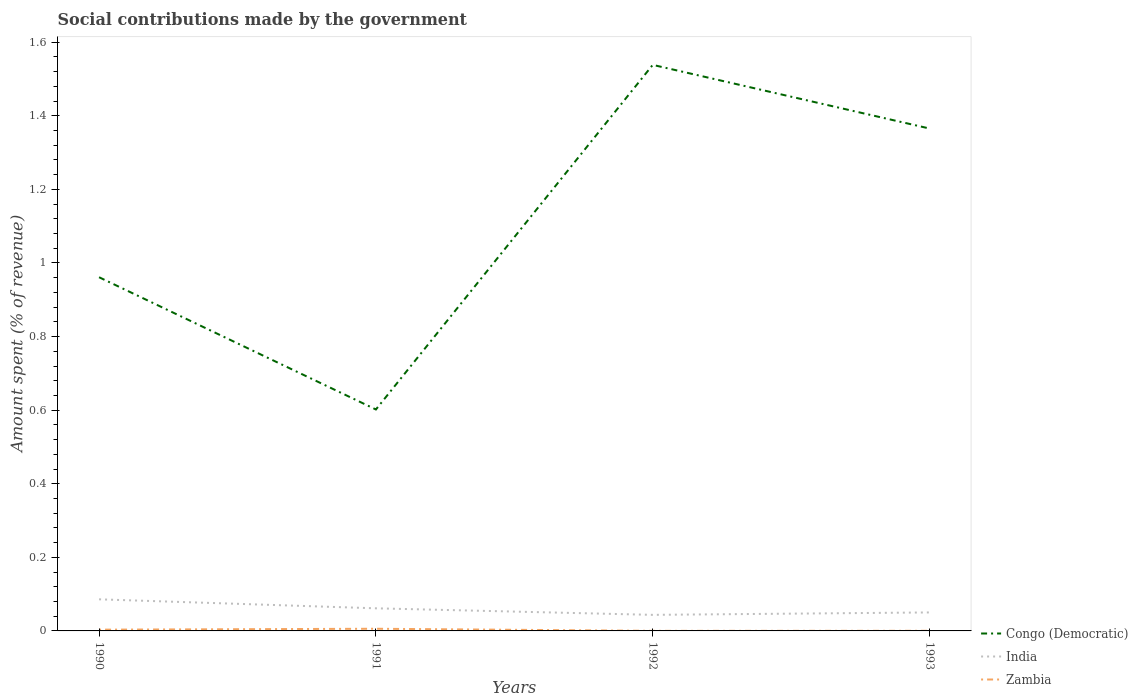Does the line corresponding to India intersect with the line corresponding to Zambia?
Your response must be concise. No. Across all years, what is the maximum amount spent (in %) on social contributions in Congo (Democratic)?
Your answer should be very brief. 0.6. In which year was the amount spent (in %) on social contributions in Zambia maximum?
Keep it short and to the point. 1992. What is the total amount spent (in %) on social contributions in India in the graph?
Your answer should be very brief. 0.02. What is the difference between the highest and the second highest amount spent (in %) on social contributions in India?
Offer a terse response. 0.04. What is the difference between the highest and the lowest amount spent (in %) on social contributions in Congo (Democratic)?
Your answer should be very brief. 2. Is the amount spent (in %) on social contributions in Zambia strictly greater than the amount spent (in %) on social contributions in Congo (Democratic) over the years?
Give a very brief answer. Yes. How many lines are there?
Ensure brevity in your answer.  3. Does the graph contain grids?
Your answer should be compact. No. Where does the legend appear in the graph?
Offer a terse response. Bottom right. How many legend labels are there?
Offer a very short reply. 3. How are the legend labels stacked?
Ensure brevity in your answer.  Vertical. What is the title of the graph?
Provide a succinct answer. Social contributions made by the government. What is the label or title of the X-axis?
Offer a very short reply. Years. What is the label or title of the Y-axis?
Give a very brief answer. Amount spent (% of revenue). What is the Amount spent (% of revenue) of Congo (Democratic) in 1990?
Your answer should be very brief. 0.96. What is the Amount spent (% of revenue) of India in 1990?
Give a very brief answer. 0.09. What is the Amount spent (% of revenue) of Zambia in 1990?
Provide a succinct answer. 0. What is the Amount spent (% of revenue) in Congo (Democratic) in 1991?
Your response must be concise. 0.6. What is the Amount spent (% of revenue) of India in 1991?
Provide a succinct answer. 0.06. What is the Amount spent (% of revenue) in Zambia in 1991?
Offer a very short reply. 0.01. What is the Amount spent (% of revenue) in Congo (Democratic) in 1992?
Keep it short and to the point. 1.54. What is the Amount spent (% of revenue) in India in 1992?
Make the answer very short. 0.04. What is the Amount spent (% of revenue) of Zambia in 1992?
Your answer should be compact. 0. What is the Amount spent (% of revenue) of Congo (Democratic) in 1993?
Provide a succinct answer. 1.37. What is the Amount spent (% of revenue) in India in 1993?
Give a very brief answer. 0.05. What is the Amount spent (% of revenue) in Zambia in 1993?
Give a very brief answer. 0. Across all years, what is the maximum Amount spent (% of revenue) in Congo (Democratic)?
Make the answer very short. 1.54. Across all years, what is the maximum Amount spent (% of revenue) in India?
Ensure brevity in your answer.  0.09. Across all years, what is the maximum Amount spent (% of revenue) in Zambia?
Make the answer very short. 0.01. Across all years, what is the minimum Amount spent (% of revenue) in Congo (Democratic)?
Keep it short and to the point. 0.6. Across all years, what is the minimum Amount spent (% of revenue) of India?
Offer a very short reply. 0.04. Across all years, what is the minimum Amount spent (% of revenue) in Zambia?
Offer a very short reply. 0. What is the total Amount spent (% of revenue) of Congo (Democratic) in the graph?
Offer a very short reply. 4.47. What is the total Amount spent (% of revenue) of India in the graph?
Your answer should be compact. 0.24. What is the total Amount spent (% of revenue) of Zambia in the graph?
Give a very brief answer. 0.01. What is the difference between the Amount spent (% of revenue) in Congo (Democratic) in 1990 and that in 1991?
Ensure brevity in your answer.  0.36. What is the difference between the Amount spent (% of revenue) in India in 1990 and that in 1991?
Offer a very short reply. 0.02. What is the difference between the Amount spent (% of revenue) in Zambia in 1990 and that in 1991?
Your answer should be very brief. -0. What is the difference between the Amount spent (% of revenue) in Congo (Democratic) in 1990 and that in 1992?
Provide a short and direct response. -0.58. What is the difference between the Amount spent (% of revenue) of India in 1990 and that in 1992?
Give a very brief answer. 0.04. What is the difference between the Amount spent (% of revenue) of Zambia in 1990 and that in 1992?
Provide a succinct answer. 0. What is the difference between the Amount spent (% of revenue) in Congo (Democratic) in 1990 and that in 1993?
Make the answer very short. -0.4. What is the difference between the Amount spent (% of revenue) of India in 1990 and that in 1993?
Give a very brief answer. 0.04. What is the difference between the Amount spent (% of revenue) in Zambia in 1990 and that in 1993?
Keep it short and to the point. 0. What is the difference between the Amount spent (% of revenue) of Congo (Democratic) in 1991 and that in 1992?
Provide a succinct answer. -0.94. What is the difference between the Amount spent (% of revenue) of India in 1991 and that in 1992?
Offer a very short reply. 0.02. What is the difference between the Amount spent (% of revenue) of Zambia in 1991 and that in 1992?
Provide a short and direct response. 0.01. What is the difference between the Amount spent (% of revenue) in Congo (Democratic) in 1991 and that in 1993?
Ensure brevity in your answer.  -0.76. What is the difference between the Amount spent (% of revenue) in India in 1991 and that in 1993?
Give a very brief answer. 0.01. What is the difference between the Amount spent (% of revenue) of Zambia in 1991 and that in 1993?
Give a very brief answer. 0.01. What is the difference between the Amount spent (% of revenue) of Congo (Democratic) in 1992 and that in 1993?
Offer a very short reply. 0.17. What is the difference between the Amount spent (% of revenue) in India in 1992 and that in 1993?
Keep it short and to the point. -0.01. What is the difference between the Amount spent (% of revenue) in Zambia in 1992 and that in 1993?
Your answer should be compact. -0. What is the difference between the Amount spent (% of revenue) of Congo (Democratic) in 1990 and the Amount spent (% of revenue) of India in 1991?
Give a very brief answer. 0.9. What is the difference between the Amount spent (% of revenue) in Congo (Democratic) in 1990 and the Amount spent (% of revenue) in Zambia in 1991?
Offer a very short reply. 0.96. What is the difference between the Amount spent (% of revenue) in India in 1990 and the Amount spent (% of revenue) in Zambia in 1991?
Provide a short and direct response. 0.08. What is the difference between the Amount spent (% of revenue) of Congo (Democratic) in 1990 and the Amount spent (% of revenue) of India in 1992?
Provide a succinct answer. 0.92. What is the difference between the Amount spent (% of revenue) in Congo (Democratic) in 1990 and the Amount spent (% of revenue) in Zambia in 1992?
Offer a terse response. 0.96. What is the difference between the Amount spent (% of revenue) in India in 1990 and the Amount spent (% of revenue) in Zambia in 1992?
Provide a short and direct response. 0.09. What is the difference between the Amount spent (% of revenue) of Congo (Democratic) in 1990 and the Amount spent (% of revenue) of India in 1993?
Provide a short and direct response. 0.91. What is the difference between the Amount spent (% of revenue) of Congo (Democratic) in 1990 and the Amount spent (% of revenue) of Zambia in 1993?
Ensure brevity in your answer.  0.96. What is the difference between the Amount spent (% of revenue) of India in 1990 and the Amount spent (% of revenue) of Zambia in 1993?
Ensure brevity in your answer.  0.09. What is the difference between the Amount spent (% of revenue) of Congo (Democratic) in 1991 and the Amount spent (% of revenue) of India in 1992?
Your answer should be compact. 0.56. What is the difference between the Amount spent (% of revenue) in Congo (Democratic) in 1991 and the Amount spent (% of revenue) in Zambia in 1992?
Give a very brief answer. 0.6. What is the difference between the Amount spent (% of revenue) of India in 1991 and the Amount spent (% of revenue) of Zambia in 1992?
Ensure brevity in your answer.  0.06. What is the difference between the Amount spent (% of revenue) in Congo (Democratic) in 1991 and the Amount spent (% of revenue) in India in 1993?
Your answer should be very brief. 0.55. What is the difference between the Amount spent (% of revenue) in Congo (Democratic) in 1991 and the Amount spent (% of revenue) in Zambia in 1993?
Give a very brief answer. 0.6. What is the difference between the Amount spent (% of revenue) of India in 1991 and the Amount spent (% of revenue) of Zambia in 1993?
Make the answer very short. 0.06. What is the difference between the Amount spent (% of revenue) in Congo (Democratic) in 1992 and the Amount spent (% of revenue) in India in 1993?
Ensure brevity in your answer.  1.49. What is the difference between the Amount spent (% of revenue) of Congo (Democratic) in 1992 and the Amount spent (% of revenue) of Zambia in 1993?
Offer a very short reply. 1.54. What is the difference between the Amount spent (% of revenue) of India in 1992 and the Amount spent (% of revenue) of Zambia in 1993?
Your answer should be compact. 0.04. What is the average Amount spent (% of revenue) in Congo (Democratic) per year?
Give a very brief answer. 1.12. What is the average Amount spent (% of revenue) in India per year?
Offer a very short reply. 0.06. What is the average Amount spent (% of revenue) in Zambia per year?
Offer a very short reply. 0. In the year 1990, what is the difference between the Amount spent (% of revenue) of Congo (Democratic) and Amount spent (% of revenue) of India?
Offer a very short reply. 0.88. In the year 1990, what is the difference between the Amount spent (% of revenue) in Congo (Democratic) and Amount spent (% of revenue) in Zambia?
Ensure brevity in your answer.  0.96. In the year 1990, what is the difference between the Amount spent (% of revenue) of India and Amount spent (% of revenue) of Zambia?
Ensure brevity in your answer.  0.08. In the year 1991, what is the difference between the Amount spent (% of revenue) in Congo (Democratic) and Amount spent (% of revenue) in India?
Your answer should be very brief. 0.54. In the year 1991, what is the difference between the Amount spent (% of revenue) in Congo (Democratic) and Amount spent (% of revenue) in Zambia?
Your answer should be compact. 0.6. In the year 1991, what is the difference between the Amount spent (% of revenue) of India and Amount spent (% of revenue) of Zambia?
Provide a succinct answer. 0.06. In the year 1992, what is the difference between the Amount spent (% of revenue) of Congo (Democratic) and Amount spent (% of revenue) of India?
Ensure brevity in your answer.  1.49. In the year 1992, what is the difference between the Amount spent (% of revenue) of Congo (Democratic) and Amount spent (% of revenue) of Zambia?
Make the answer very short. 1.54. In the year 1992, what is the difference between the Amount spent (% of revenue) in India and Amount spent (% of revenue) in Zambia?
Give a very brief answer. 0.04. In the year 1993, what is the difference between the Amount spent (% of revenue) of Congo (Democratic) and Amount spent (% of revenue) of India?
Offer a very short reply. 1.32. In the year 1993, what is the difference between the Amount spent (% of revenue) of Congo (Democratic) and Amount spent (% of revenue) of Zambia?
Make the answer very short. 1.37. In the year 1993, what is the difference between the Amount spent (% of revenue) of India and Amount spent (% of revenue) of Zambia?
Offer a very short reply. 0.05. What is the ratio of the Amount spent (% of revenue) in Congo (Democratic) in 1990 to that in 1991?
Keep it short and to the point. 1.6. What is the ratio of the Amount spent (% of revenue) of India in 1990 to that in 1991?
Offer a terse response. 1.4. What is the ratio of the Amount spent (% of revenue) in Zambia in 1990 to that in 1991?
Make the answer very short. 0.58. What is the ratio of the Amount spent (% of revenue) in Congo (Democratic) in 1990 to that in 1992?
Your answer should be compact. 0.62. What is the ratio of the Amount spent (% of revenue) of India in 1990 to that in 1992?
Your answer should be very brief. 1.97. What is the ratio of the Amount spent (% of revenue) of Zambia in 1990 to that in 1992?
Your answer should be compact. 16.3. What is the ratio of the Amount spent (% of revenue) of Congo (Democratic) in 1990 to that in 1993?
Your answer should be very brief. 0.7. What is the ratio of the Amount spent (% of revenue) in India in 1990 to that in 1993?
Keep it short and to the point. 1.71. What is the ratio of the Amount spent (% of revenue) in Zambia in 1990 to that in 1993?
Provide a short and direct response. 10.3. What is the ratio of the Amount spent (% of revenue) of Congo (Democratic) in 1991 to that in 1992?
Your answer should be compact. 0.39. What is the ratio of the Amount spent (% of revenue) in India in 1991 to that in 1992?
Offer a very short reply. 1.41. What is the ratio of the Amount spent (% of revenue) in Zambia in 1991 to that in 1992?
Provide a succinct answer. 28.1. What is the ratio of the Amount spent (% of revenue) in Congo (Democratic) in 1991 to that in 1993?
Your answer should be compact. 0.44. What is the ratio of the Amount spent (% of revenue) in India in 1991 to that in 1993?
Give a very brief answer. 1.22. What is the ratio of the Amount spent (% of revenue) of Zambia in 1991 to that in 1993?
Give a very brief answer. 17.76. What is the ratio of the Amount spent (% of revenue) in Congo (Democratic) in 1992 to that in 1993?
Make the answer very short. 1.13. What is the ratio of the Amount spent (% of revenue) of India in 1992 to that in 1993?
Offer a very short reply. 0.87. What is the ratio of the Amount spent (% of revenue) of Zambia in 1992 to that in 1993?
Offer a terse response. 0.63. What is the difference between the highest and the second highest Amount spent (% of revenue) of Congo (Democratic)?
Make the answer very short. 0.17. What is the difference between the highest and the second highest Amount spent (% of revenue) of India?
Offer a very short reply. 0.02. What is the difference between the highest and the second highest Amount spent (% of revenue) in Zambia?
Offer a very short reply. 0. What is the difference between the highest and the lowest Amount spent (% of revenue) of Congo (Democratic)?
Give a very brief answer. 0.94. What is the difference between the highest and the lowest Amount spent (% of revenue) in India?
Provide a succinct answer. 0.04. What is the difference between the highest and the lowest Amount spent (% of revenue) of Zambia?
Offer a terse response. 0.01. 